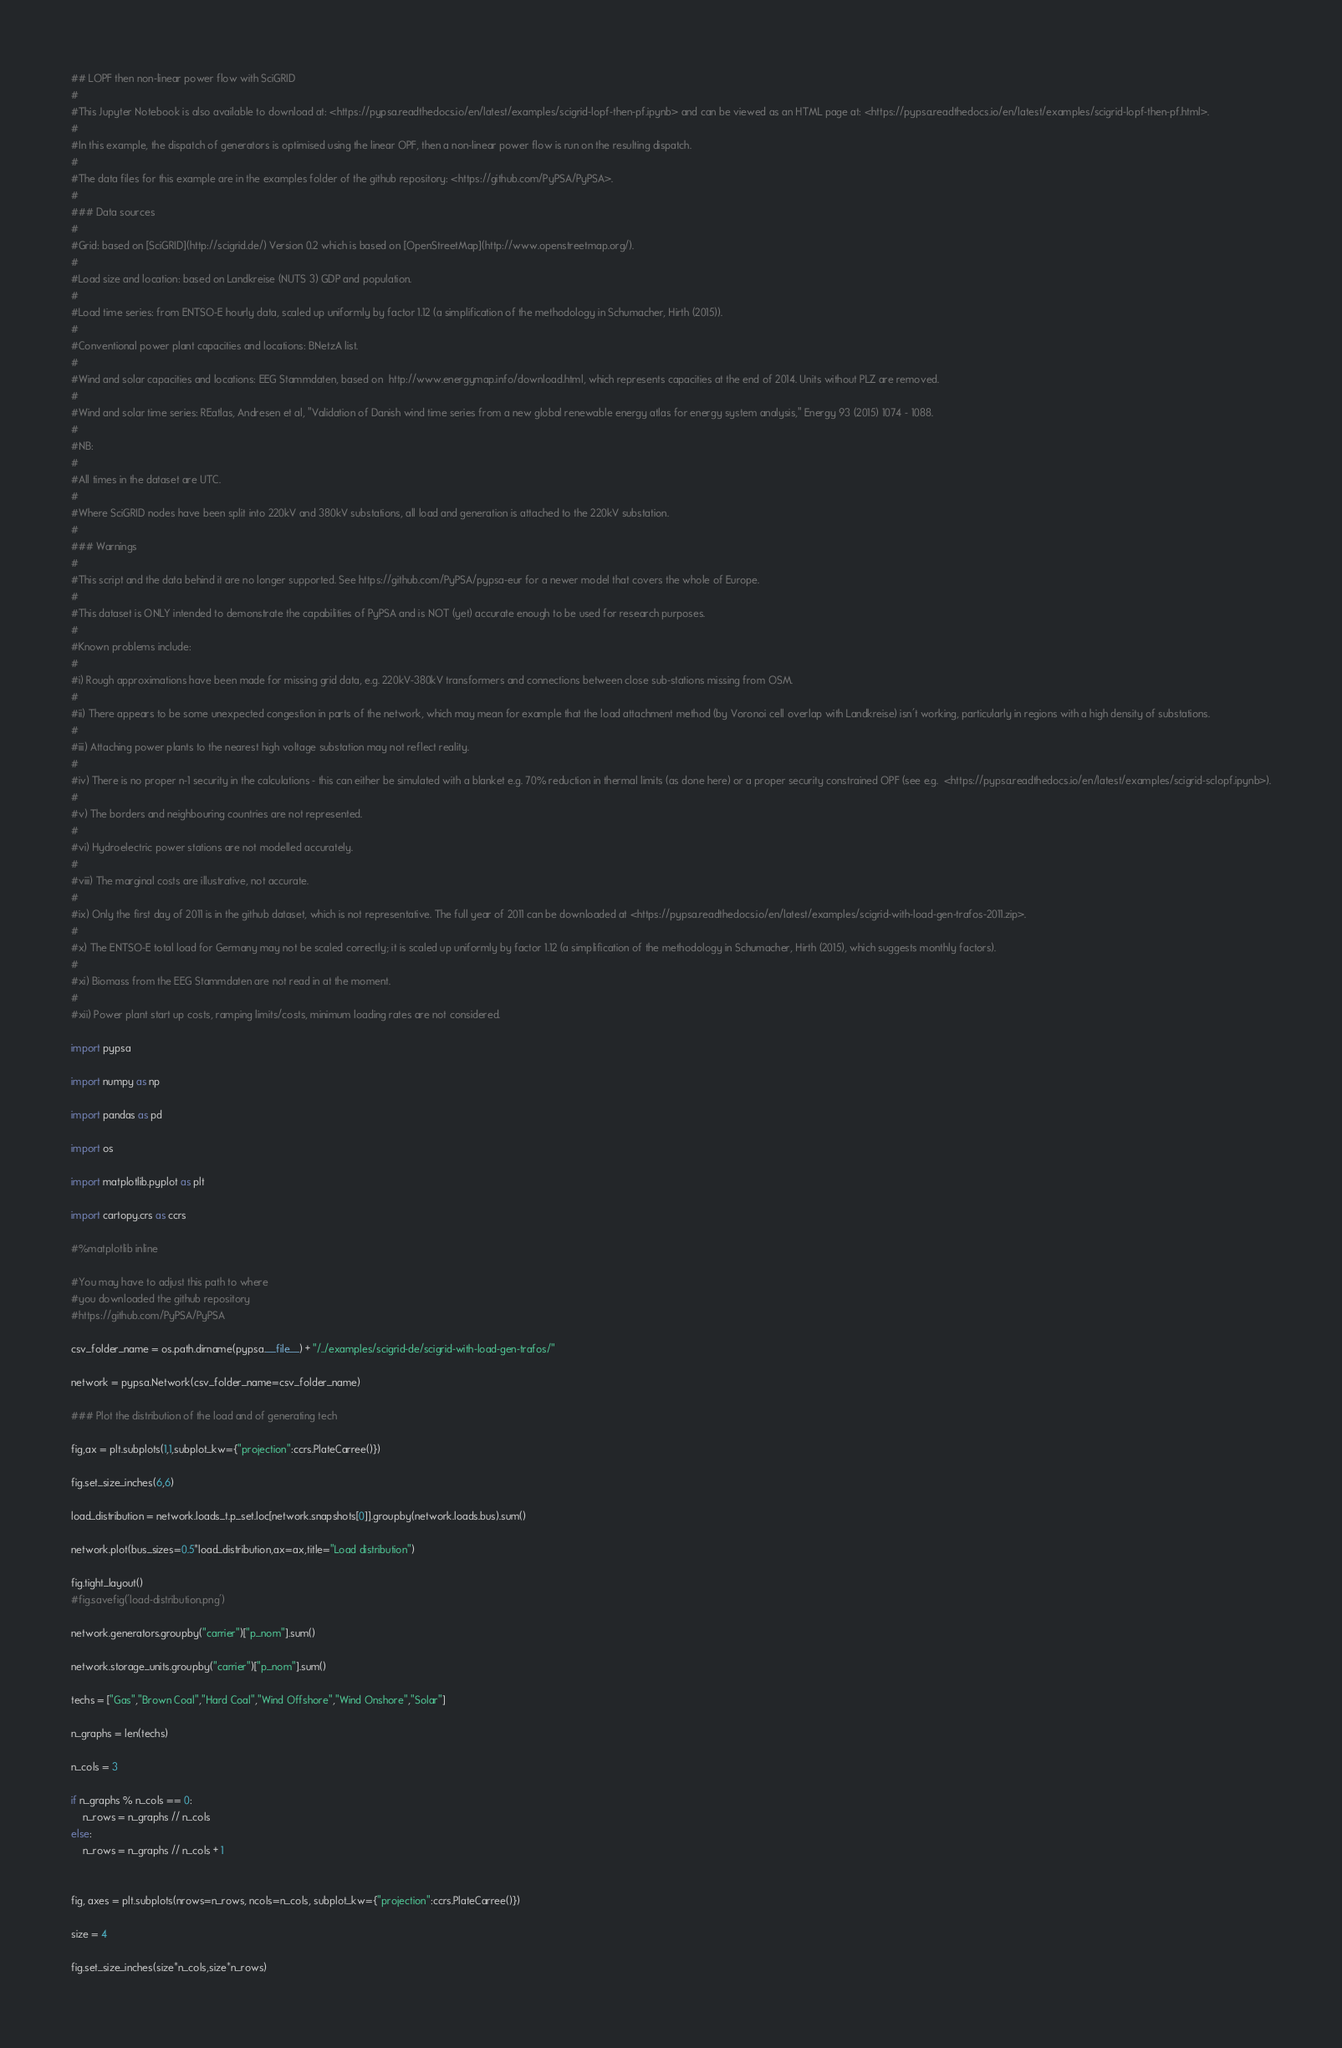Convert code to text. <code><loc_0><loc_0><loc_500><loc_500><_Python_>## LOPF then non-linear power flow with SciGRID
#
#This Jupyter Notebook is also available to download at: <https://pypsa.readthedocs.io/en/latest/examples/scigrid-lopf-then-pf.ipynb> and can be viewed as an HTML page at: <https://pypsa.readthedocs.io/en/latest/examples/scigrid-lopf-then-pf.html>.
#
#In this example, the dispatch of generators is optimised using the linear OPF, then a non-linear power flow is run on the resulting dispatch.
#
#The data files for this example are in the examples folder of the github repository: <https://github.com/PyPSA/PyPSA>.
#
### Data sources
#
#Grid: based on [SciGRID](http://scigrid.de/) Version 0.2 which is based on [OpenStreetMap](http://www.openstreetmap.org/).
#
#Load size and location: based on Landkreise (NUTS 3) GDP and population.
#
#Load time series: from ENTSO-E hourly data, scaled up uniformly by factor 1.12 (a simplification of the methodology in Schumacher, Hirth (2015)).
#
#Conventional power plant capacities and locations: BNetzA list.
#
#Wind and solar capacities and locations: EEG Stammdaten, based on  http://www.energymap.info/download.html, which represents capacities at the end of 2014. Units without PLZ are removed.
#
#Wind and solar time series: REatlas, Andresen et al, "Validation of Danish wind time series from a new global renewable energy atlas for energy system analysis," Energy 93 (2015) 1074 - 1088.
#
#NB:
#
#All times in the dataset are UTC.
#
#Where SciGRID nodes have been split into 220kV and 380kV substations, all load and generation is attached to the 220kV substation.
#
### Warnings
#
#This script and the data behind it are no longer supported. See https://github.com/PyPSA/pypsa-eur for a newer model that covers the whole of Europe.
#
#This dataset is ONLY intended to demonstrate the capabilities of PyPSA and is NOT (yet) accurate enough to be used for research purposes.
#
#Known problems include:
#
#i) Rough approximations have been made for missing grid data, e.g. 220kV-380kV transformers and connections between close sub-stations missing from OSM.
#
#ii) There appears to be some unexpected congestion in parts of the network, which may mean for example that the load attachment method (by Voronoi cell overlap with Landkreise) isn't working, particularly in regions with a high density of substations.
#
#iii) Attaching power plants to the nearest high voltage substation may not reflect reality.
#
#iv) There is no proper n-1 security in the calculations - this can either be simulated with a blanket e.g. 70% reduction in thermal limits (as done here) or a proper security constrained OPF (see e.g.  <https://pypsa.readthedocs.io/en/latest/examples/scigrid-sclopf.ipynb>).
#
#v) The borders and neighbouring countries are not represented.
#
#vi) Hydroelectric power stations are not modelled accurately.
#
#viii) The marginal costs are illustrative, not accurate.
#
#ix) Only the first day of 2011 is in the github dataset, which is not representative. The full year of 2011 can be downloaded at <https://pypsa.readthedocs.io/en/latest/examples/scigrid-with-load-gen-trafos-2011.zip>.
#
#x) The ENTSO-E total load for Germany may not be scaled correctly; it is scaled up uniformly by factor 1.12 (a simplification of the methodology in Schumacher, Hirth (2015), which suggests monthly factors).
#
#xi) Biomass from the EEG Stammdaten are not read in at the moment.
#
#xii) Power plant start up costs, ramping limits/costs, minimum loading rates are not considered.

import pypsa

import numpy as np

import pandas as pd

import os

import matplotlib.pyplot as plt

import cartopy.crs as ccrs

#%matplotlib inline

#You may have to adjust this path to where 
#you downloaded the github repository
#https://github.com/PyPSA/PyPSA

csv_folder_name = os.path.dirname(pypsa.__file__) + "/../examples/scigrid-de/scigrid-with-load-gen-trafos/"

network = pypsa.Network(csv_folder_name=csv_folder_name)

### Plot the distribution of the load and of generating tech

fig,ax = plt.subplots(1,1,subplot_kw={"projection":ccrs.PlateCarree()})

fig.set_size_inches(6,6)

load_distribution = network.loads_t.p_set.loc[network.snapshots[0]].groupby(network.loads.bus).sum()

network.plot(bus_sizes=0.5*load_distribution,ax=ax,title="Load distribution")

fig.tight_layout()
#fig.savefig('load-distribution.png')

network.generators.groupby("carrier")["p_nom"].sum()

network.storage_units.groupby("carrier")["p_nom"].sum()

techs = ["Gas","Brown Coal","Hard Coal","Wind Offshore","Wind Onshore","Solar"]

n_graphs = len(techs)

n_cols = 3

if n_graphs % n_cols == 0:
    n_rows = n_graphs // n_cols
else:
    n_rows = n_graphs // n_cols + 1

    
fig, axes = plt.subplots(nrows=n_rows, ncols=n_cols, subplot_kw={"projection":ccrs.PlateCarree()})

size = 4

fig.set_size_inches(size*n_cols,size*n_rows)
</code> 